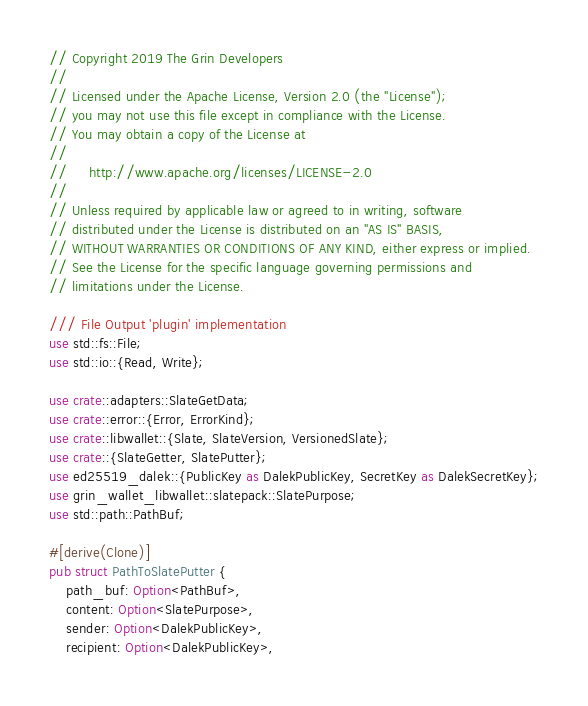Convert code to text. <code><loc_0><loc_0><loc_500><loc_500><_Rust_>// Copyright 2019 The Grin Developers
//
// Licensed under the Apache License, Version 2.0 (the "License");
// you may not use this file except in compliance with the License.
// You may obtain a copy of the License at
//
//     http://www.apache.org/licenses/LICENSE-2.0
//
// Unless required by applicable law or agreed to in writing, software
// distributed under the License is distributed on an "AS IS" BASIS,
// WITHOUT WARRANTIES OR CONDITIONS OF ANY KIND, either express or implied.
// See the License for the specific language governing permissions and
// limitations under the License.

/// File Output 'plugin' implementation
use std::fs::File;
use std::io::{Read, Write};

use crate::adapters::SlateGetData;
use crate::error::{Error, ErrorKind};
use crate::libwallet::{Slate, SlateVersion, VersionedSlate};
use crate::{SlateGetter, SlatePutter};
use ed25519_dalek::{PublicKey as DalekPublicKey, SecretKey as DalekSecretKey};
use grin_wallet_libwallet::slatepack::SlatePurpose;
use std::path::PathBuf;

#[derive(Clone)]
pub struct PathToSlatePutter {
	path_buf: Option<PathBuf>,
	content: Option<SlatePurpose>,
	sender: Option<DalekPublicKey>,
	recipient: Option<DalekPublicKey>,</code> 